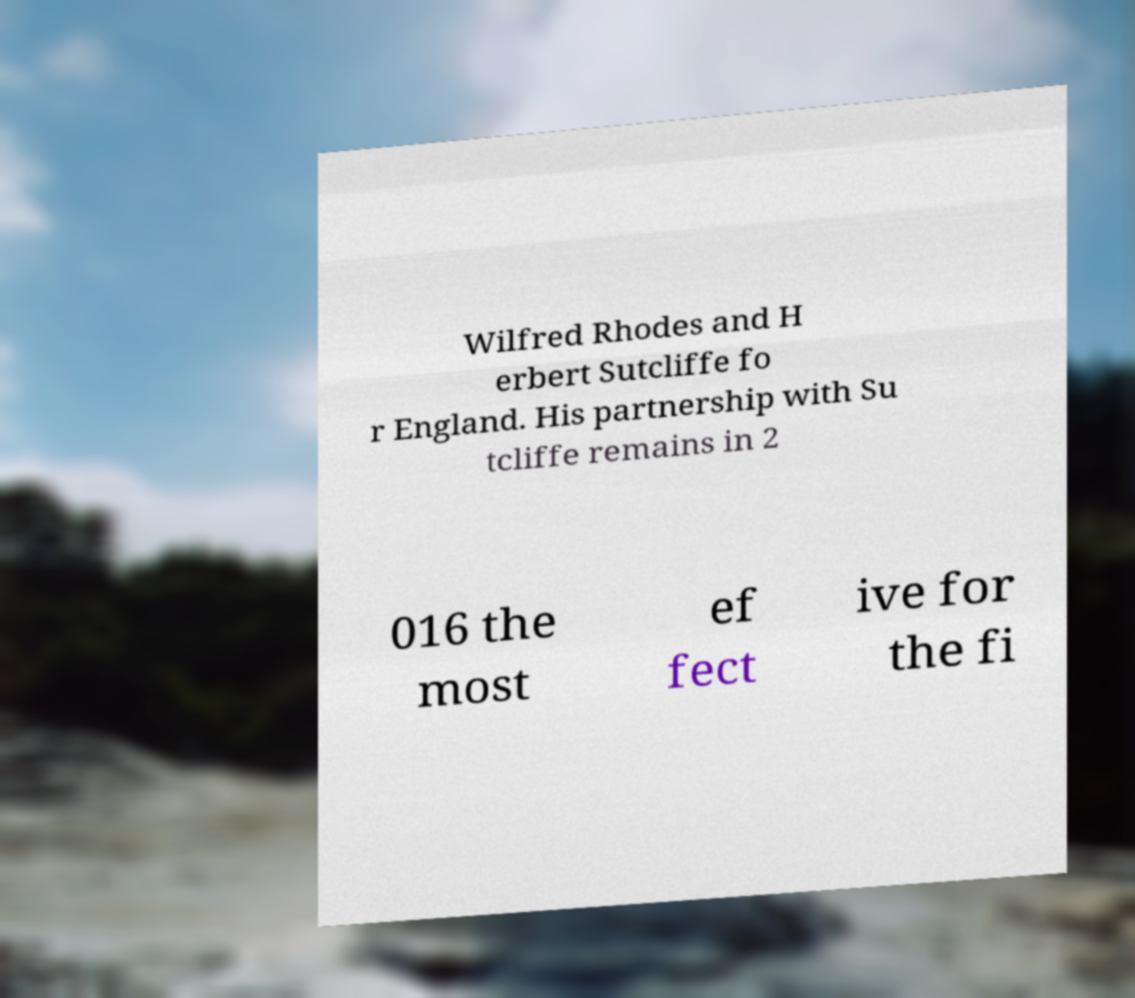Could you assist in decoding the text presented in this image and type it out clearly? Wilfred Rhodes and H erbert Sutcliffe fo r England. His partnership with Su tcliffe remains in 2 016 the most ef fect ive for the fi 